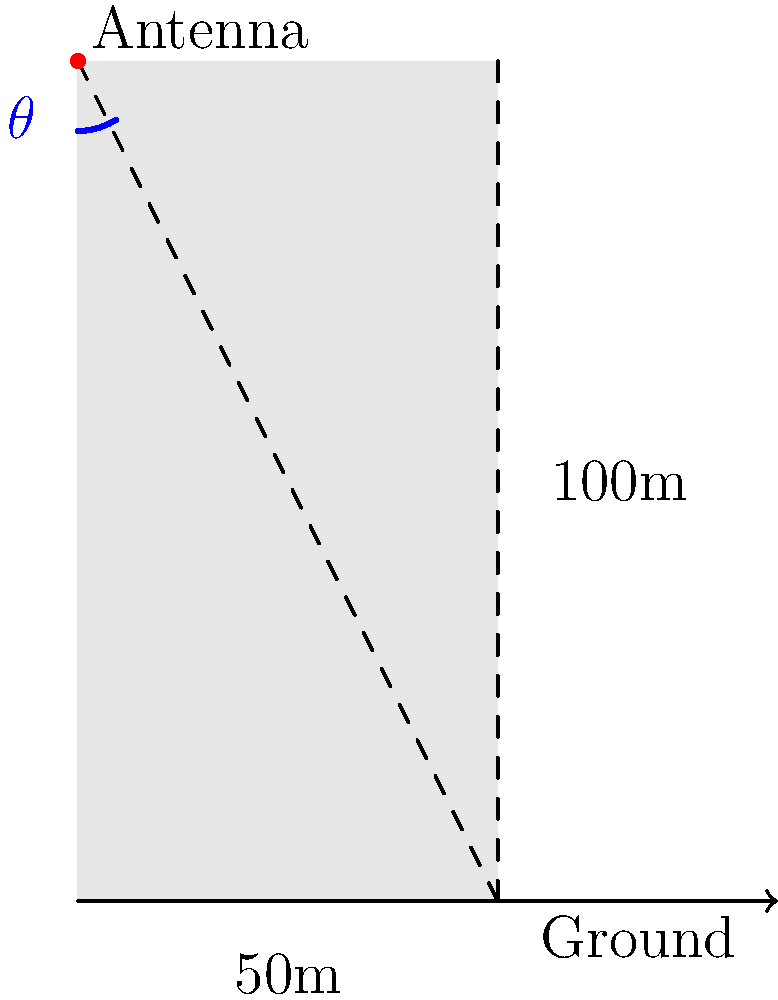A Wi-Fi antenna needs to be installed at the top corner of a 100-meter tall smart apartment building to provide optimal coverage. The building has a width of 50 meters. To ensure the best signal strength at ground level on the opposite corner, at what angle $\theta$ (measured from the vertical) should the antenna be positioned? To solve this problem, we'll use trigonometry. Let's break it down step by step:

1) We have a right triangle formed by the building and the antenna's signal path.

2) The height of the building is 100 meters (adjacent side to our angle $\theta$).

3) The width of the building is 50 meters (opposite side to our angle $\theta$).

4) We need to find the angle $\theta$ between the vertical line and the hypotenuse (signal path).

5) This is a perfect scenario for using the arctangent function, as we know the opposite and adjacent sides.

6) The formula for arctangent is:

   $\theta = \arctan(\frac{\text{opposite}}{\text{adjacent}})$

7) Plugging in our values:

   $\theta = \arctan(\frac{50}{100})$

8) Simplify:

   $\theta = \arctan(0.5)$

9) Calculate:

   $\theta \approx 26.57°$

Therefore, the antenna should be positioned at approximately 26.57° from the vertical for optimal coverage.
Answer: $26.57°$ 